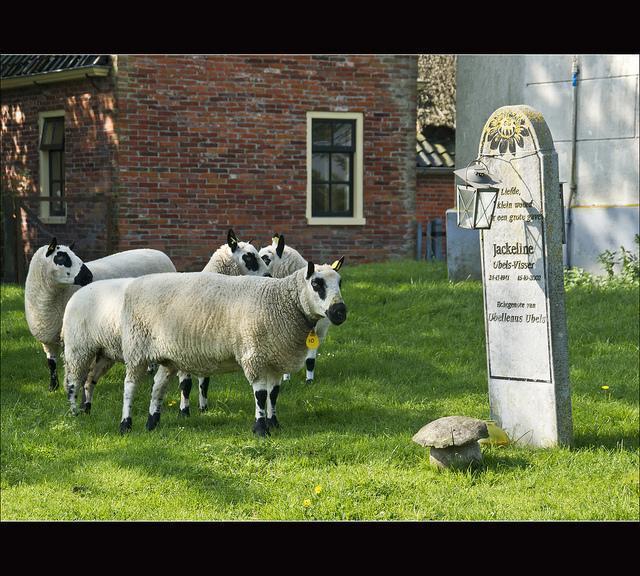How many animals are there?
Give a very brief answer. 4. How many of the sheep are young?
Give a very brief answer. 0. How many sheep can you see?
Give a very brief answer. 3. How many people are wearing black coats?
Give a very brief answer. 0. 